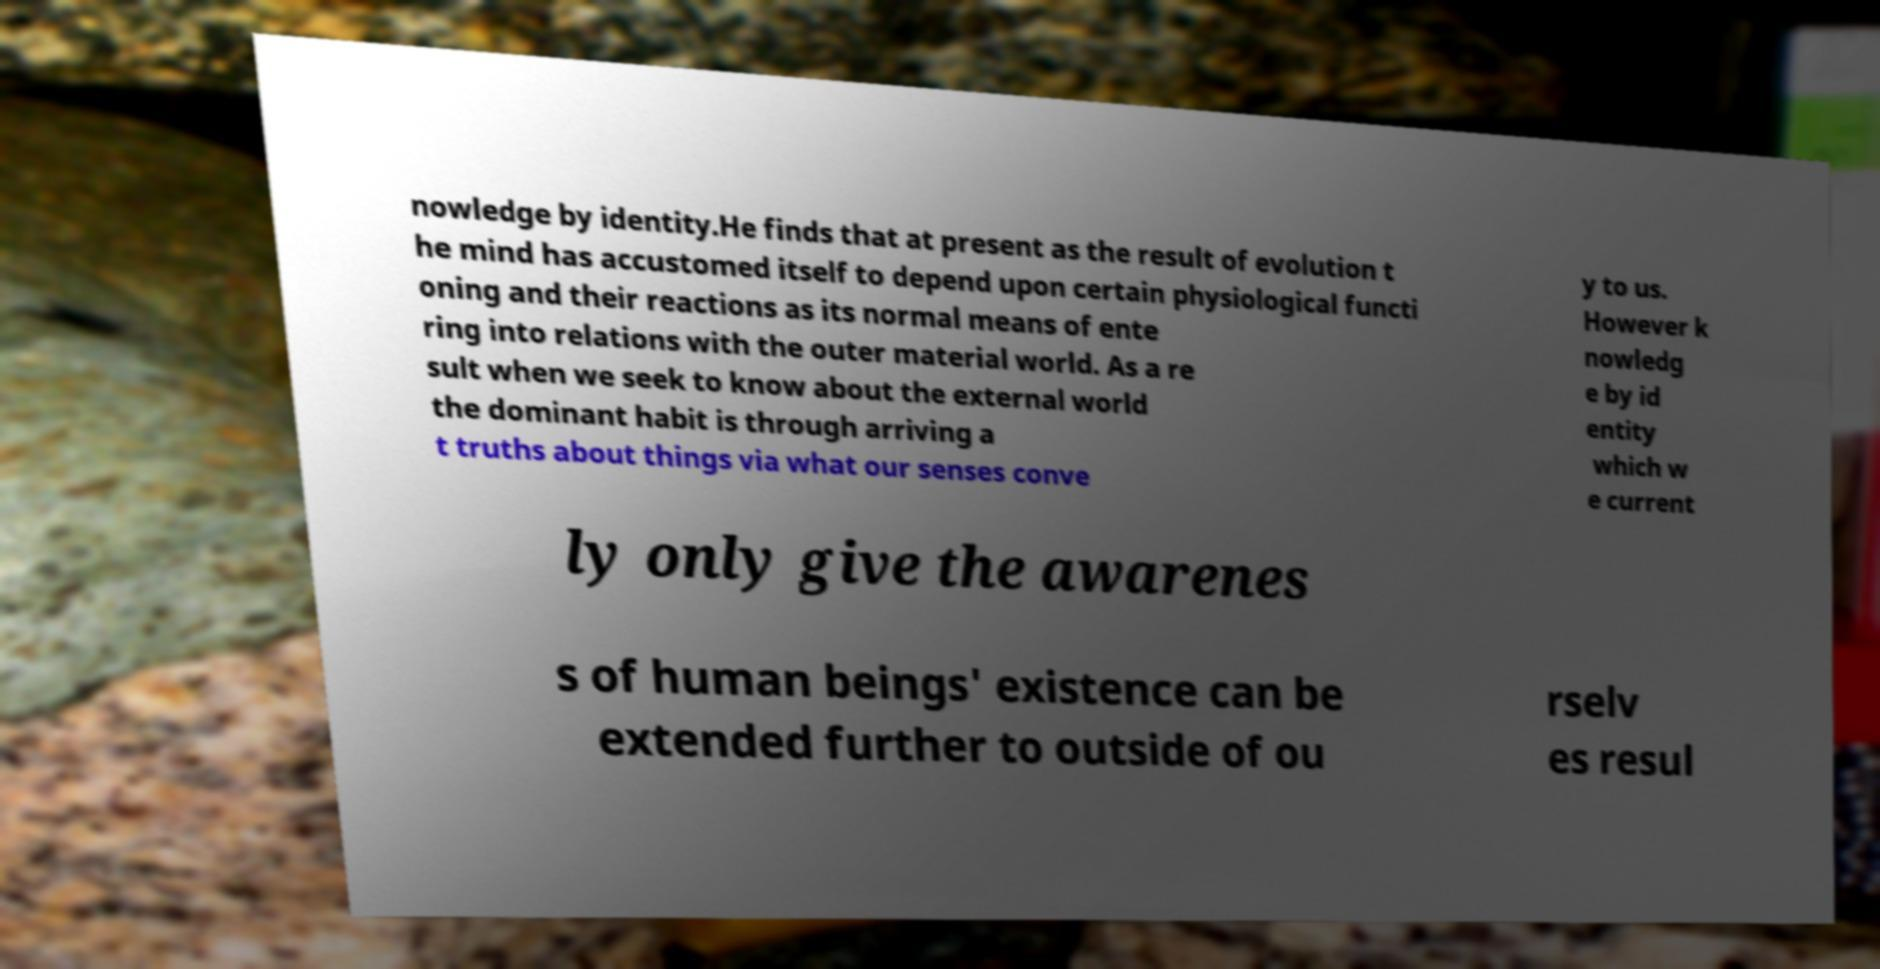Could you extract and type out the text from this image? nowledge by identity.He finds that at present as the result of evolution t he mind has accustomed itself to depend upon certain physiological functi oning and their reactions as its normal means of ente ring into relations with the outer material world. As a re sult when we seek to know about the external world the dominant habit is through arriving a t truths about things via what our senses conve y to us. However k nowledg e by id entity which w e current ly only give the awarenes s of human beings' existence can be extended further to outside of ou rselv es resul 